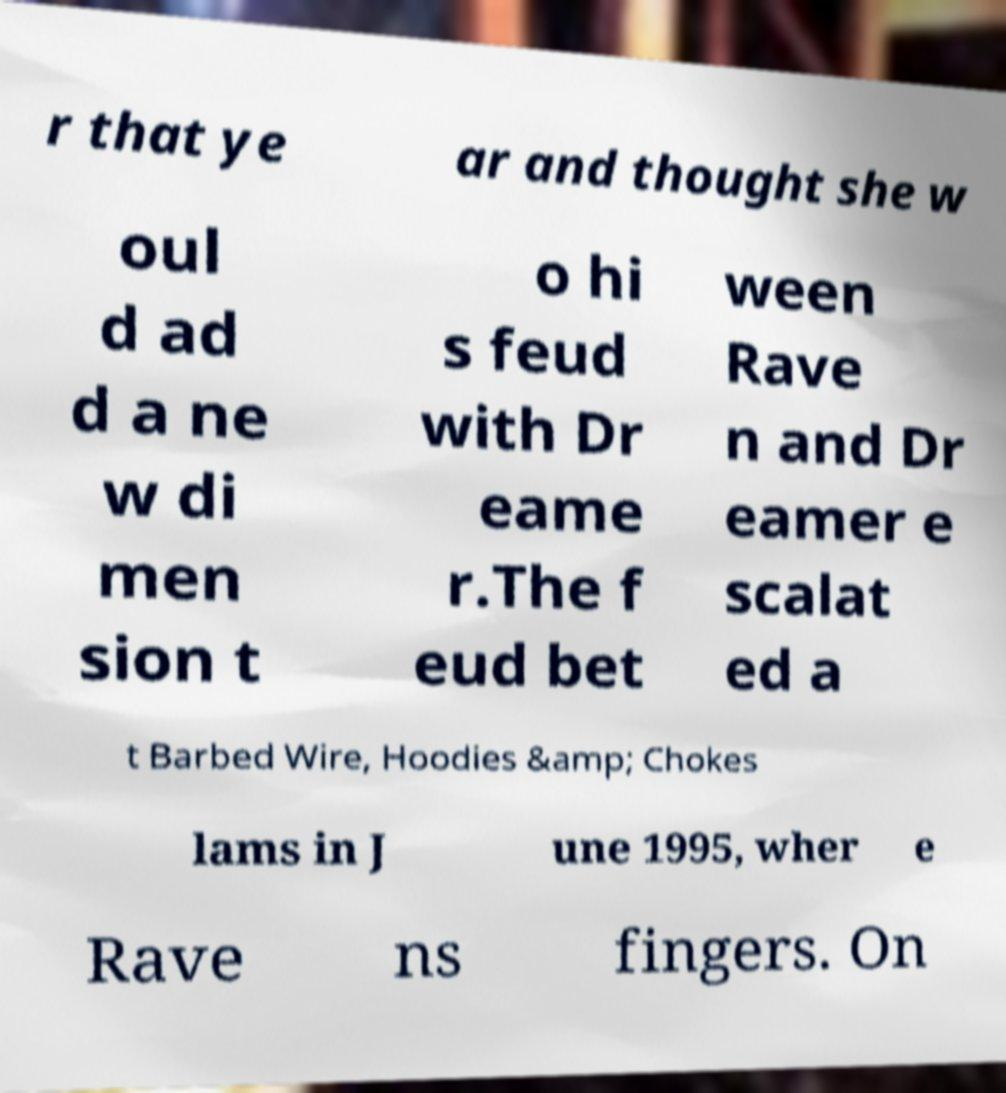Please read and relay the text visible in this image. What does it say? r that ye ar and thought she w oul d ad d a ne w di men sion t o hi s feud with Dr eame r.The f eud bet ween Rave n and Dr eamer e scalat ed a t Barbed Wire, Hoodies &amp; Chokes lams in J une 1995, wher e Rave ns fingers. On 